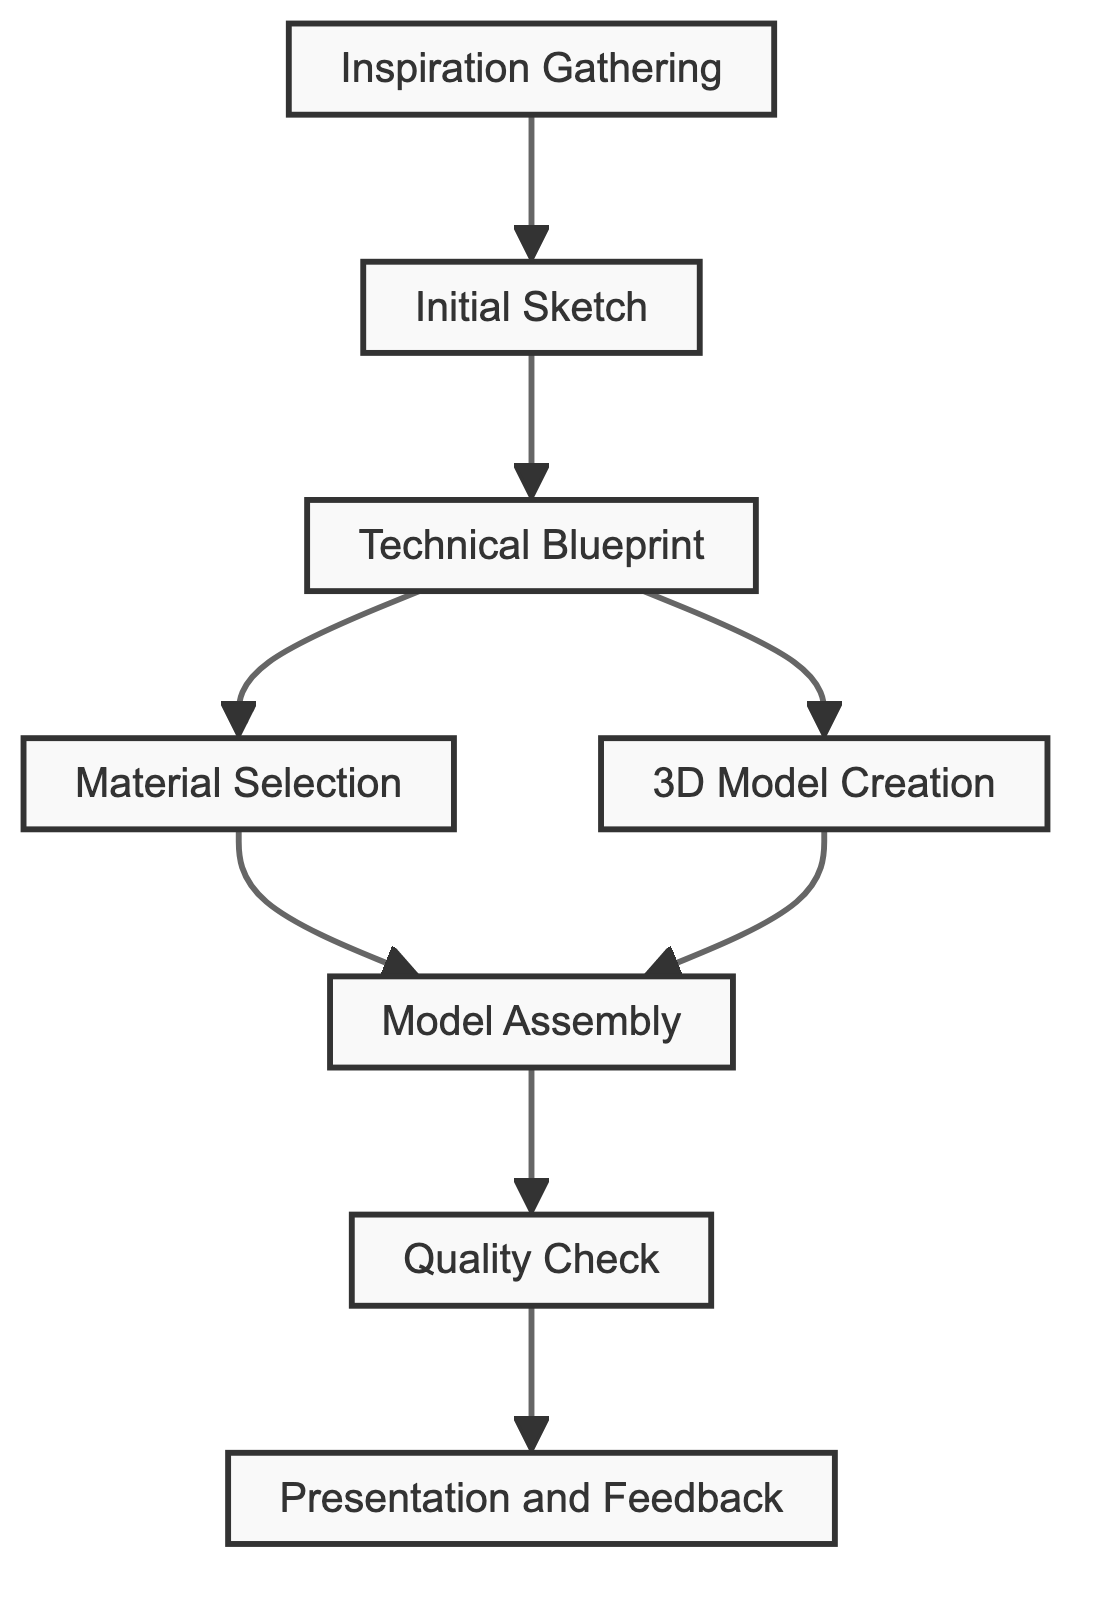What is the first step in the workflow process? The first step in the workflow process is labeled as "Inspiration Gathering." The diagram indicates that this is the initial node from which the process begins.
Answer: Inspiration Gathering How many nodes are present in the workflow process? By counting all distinct elements in the diagram, we find that there are eight nodes total, representing individual steps in the process.
Answer: 8 Which node comes after "Technical Blueprint"? The flow from "Technical Blueprint" splits into two pathways leading to "Material Selection" and "3D Model Creation." This means that both of these nodes follow "Technical Blueprint."
Answer: Material Selection and 3D Model Creation What is the last step in the workflow process? The last step in the workflow process is represented as "Presentation and Feedback." This node is the final destination without any subsequent connections.
Answer: Presentation and Feedback How many paths lead out of "Technical Blueprint"? From the "Technical Blueprint" node, there are two outgoing edges converging to "Material Selection" and "3D Model Creation," indicating two distinct paths.
Answer: 2 Which node requires a quality check? The "Quality Check" node follows the "Model Assembly" step in the workflow, indicating that a quality check is necessary at this point in the process.
Answer: Quality Check What are the two nodes that precede "Model Assembly"? The nodes that lead into "Model Assembly" are "Material Selection" and "3D Model Creation." Both of these steps are critical before moving on to assembly.
Answer: Material Selection and 3D Model Creation Which node is directly connected to "Quality Check"? The "Quality Check" node is directly connected to "Model Assembly," showing that the quality check occurs after the assembly of the model.
Answer: Model Assembly 